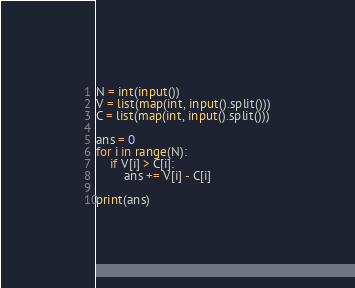<code> <loc_0><loc_0><loc_500><loc_500><_Python_>N = int(input())
V = list(map(int, input().split()))
C = list(map(int, input().split()))

ans = 0
for i in range(N):
    if V[i] > C[i]:
        ans += V[i] - C[i]

print(ans)</code> 